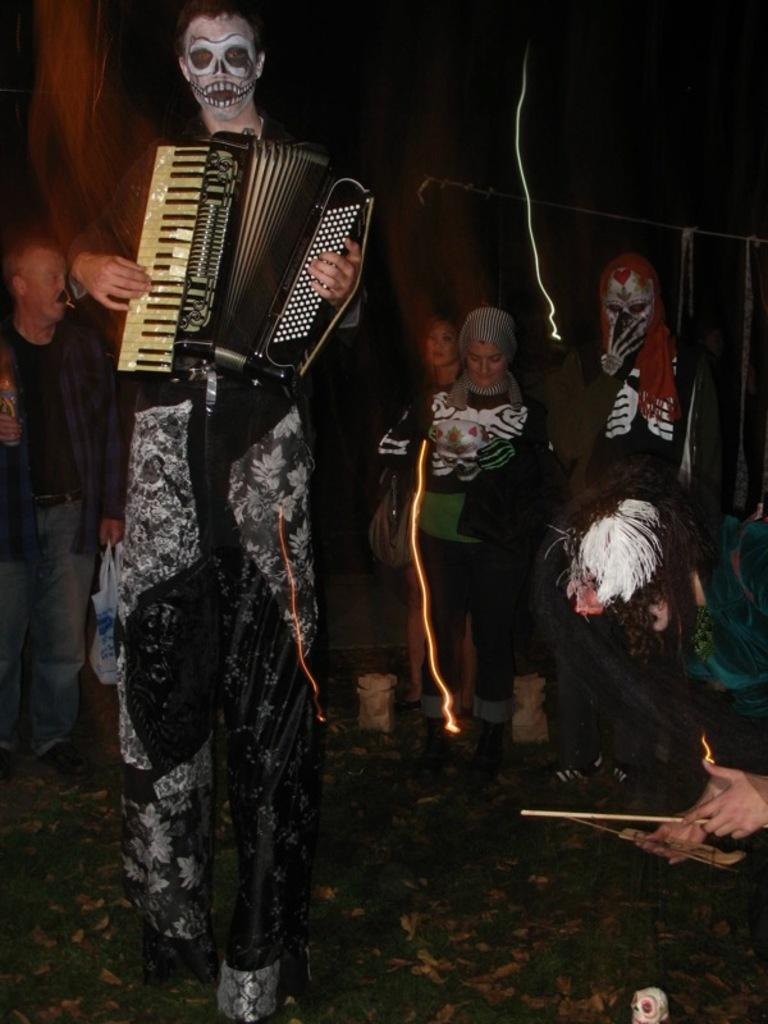What is the main activity being performed by the person in the image? There is a person playing a musical instrument in the image. What can be observed about the person's attire in the image? The person is dressed in a Halloween costume. Are there any other people in the image, and if so, what can be said about their attire? Yes, there are other people dressed in Halloween costumes in the image. How much was the ticket for the daughter to attend the event in the image? There is no mention of a ticket or an event in the image, and no daughter is present. 